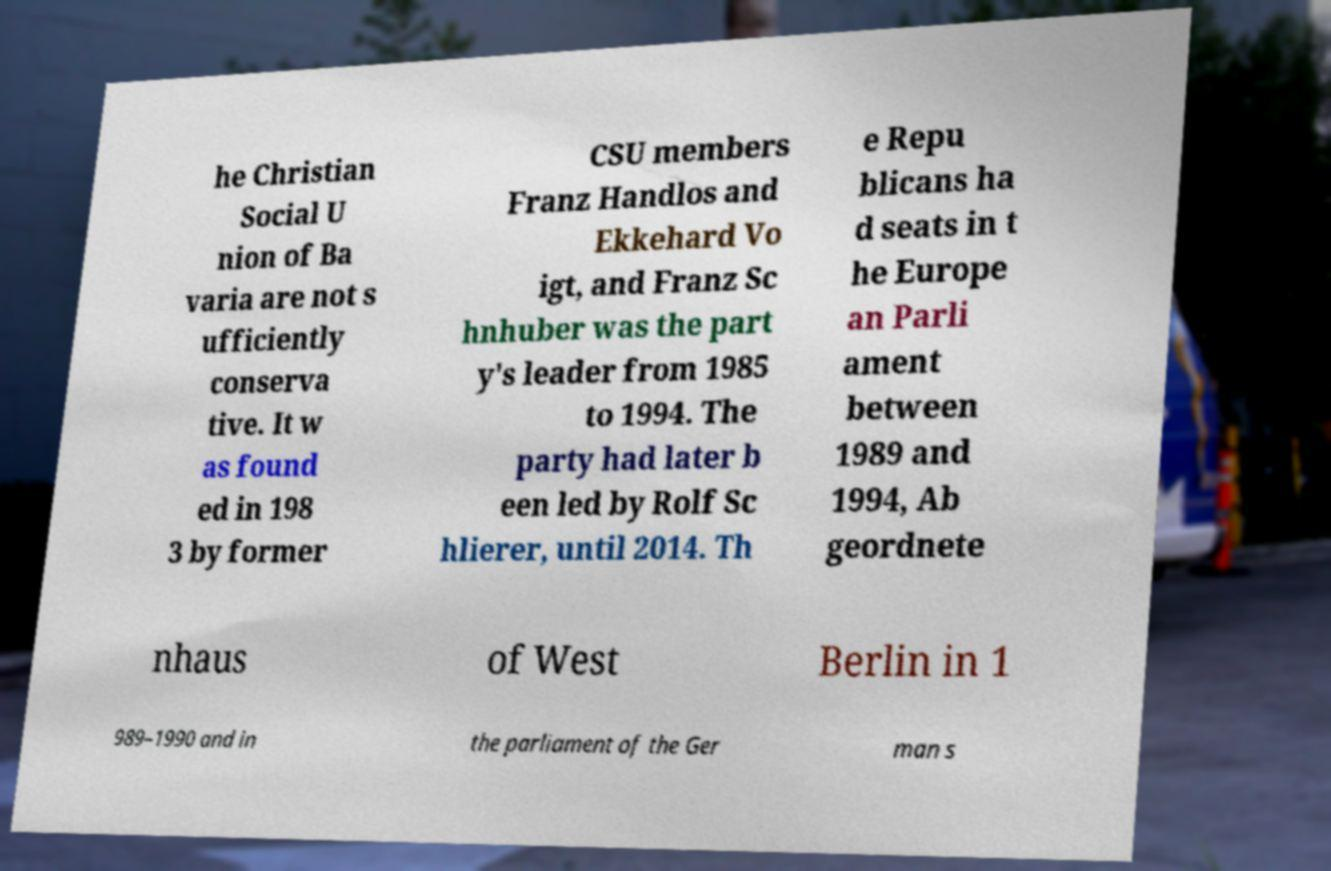What messages or text are displayed in this image? I need them in a readable, typed format. he Christian Social U nion of Ba varia are not s ufficiently conserva tive. It w as found ed in 198 3 by former CSU members Franz Handlos and Ekkehard Vo igt, and Franz Sc hnhuber was the part y's leader from 1985 to 1994. The party had later b een led by Rolf Sc hlierer, until 2014. Th e Repu blicans ha d seats in t he Europe an Parli ament between 1989 and 1994, Ab geordnete nhaus of West Berlin in 1 989–1990 and in the parliament of the Ger man s 